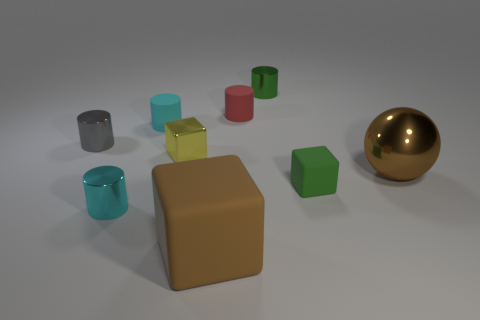Add 1 large brown matte cubes. How many objects exist? 10 Subtract all brown rubber cubes. How many cubes are left? 2 Subtract all brown cubes. How many cubes are left? 2 Subtract 1 spheres. How many spheres are left? 0 Subtract all cylinders. How many objects are left? 4 Subtract all green cubes. How many brown cylinders are left? 0 Subtract all tiny purple objects. Subtract all shiny cylinders. How many objects are left? 6 Add 5 big spheres. How many big spheres are left? 6 Add 7 small blue metallic cubes. How many small blue metallic cubes exist? 7 Subtract 0 cyan balls. How many objects are left? 9 